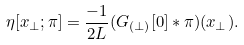Convert formula to latex. <formula><loc_0><loc_0><loc_500><loc_500>\eta [ x _ { \perp } ; \pi ] = \frac { - 1 } { 2 L } ( G _ { ( \perp ) } [ 0 ] \ast \pi ) ( x _ { \perp } ) .</formula> 